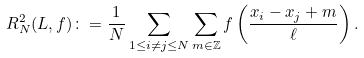<formula> <loc_0><loc_0><loc_500><loc_500>R _ { N } ^ { 2 } ( L , f ) \colon = \frac { 1 } { N } \sum _ { 1 \leq i \neq j \leq N } \sum _ { m \in \mathbb { Z } } f \left ( \frac { x _ { i } - x _ { j } + m } { \ell } \right ) .</formula> 